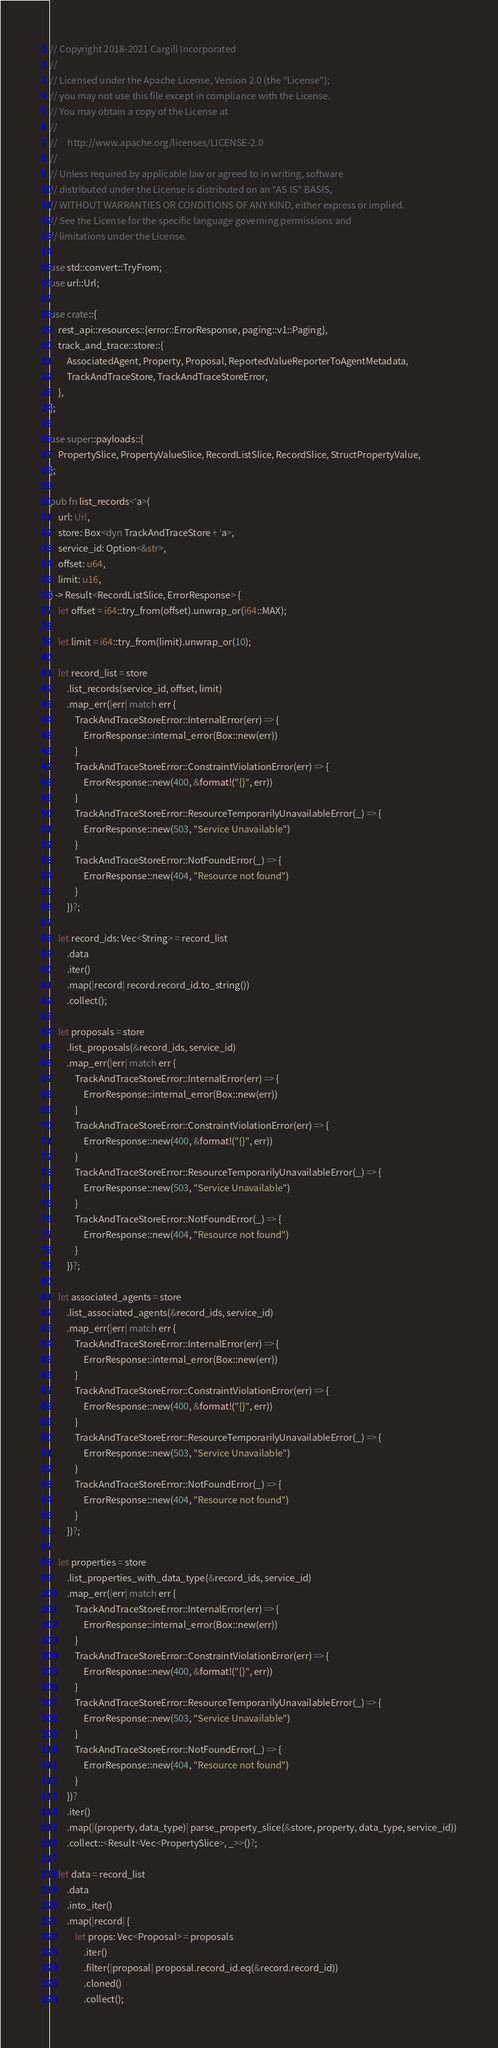<code> <loc_0><loc_0><loc_500><loc_500><_Rust_>// Copyright 2018-2021 Cargill Incorporated
//
// Licensed under the Apache License, Version 2.0 (the "License");
// you may not use this file except in compliance with the License.
// You may obtain a copy of the License at
//
//     http://www.apache.org/licenses/LICENSE-2.0
//
// Unless required by applicable law or agreed to in writing, software
// distributed under the License is distributed on an "AS IS" BASIS,
// WITHOUT WARRANTIES OR CONDITIONS OF ANY KIND, either express or implied.
// See the License for the specific language governing permissions and
// limitations under the License.

use std::convert::TryFrom;
use url::Url;

use crate::{
    rest_api::resources::{error::ErrorResponse, paging::v1::Paging},
    track_and_trace::store::{
        AssociatedAgent, Property, Proposal, ReportedValueReporterToAgentMetadata,
        TrackAndTraceStore, TrackAndTraceStoreError,
    },
};

use super::payloads::{
    PropertySlice, PropertyValueSlice, RecordListSlice, RecordSlice, StructPropertyValue,
};

pub fn list_records<'a>(
    url: Url,
    store: Box<dyn TrackAndTraceStore + 'a>,
    service_id: Option<&str>,
    offset: u64,
    limit: u16,
) -> Result<RecordListSlice, ErrorResponse> {
    let offset = i64::try_from(offset).unwrap_or(i64::MAX);

    let limit = i64::try_from(limit).unwrap_or(10);

    let record_list = store
        .list_records(service_id, offset, limit)
        .map_err(|err| match err {
            TrackAndTraceStoreError::InternalError(err) => {
                ErrorResponse::internal_error(Box::new(err))
            }
            TrackAndTraceStoreError::ConstraintViolationError(err) => {
                ErrorResponse::new(400, &format!("{}", err))
            }
            TrackAndTraceStoreError::ResourceTemporarilyUnavailableError(_) => {
                ErrorResponse::new(503, "Service Unavailable")
            }
            TrackAndTraceStoreError::NotFoundError(_) => {
                ErrorResponse::new(404, "Resource not found")
            }
        })?;

    let record_ids: Vec<String> = record_list
        .data
        .iter()
        .map(|record| record.record_id.to_string())
        .collect();

    let proposals = store
        .list_proposals(&record_ids, service_id)
        .map_err(|err| match err {
            TrackAndTraceStoreError::InternalError(err) => {
                ErrorResponse::internal_error(Box::new(err))
            }
            TrackAndTraceStoreError::ConstraintViolationError(err) => {
                ErrorResponse::new(400, &format!("{}", err))
            }
            TrackAndTraceStoreError::ResourceTemporarilyUnavailableError(_) => {
                ErrorResponse::new(503, "Service Unavailable")
            }
            TrackAndTraceStoreError::NotFoundError(_) => {
                ErrorResponse::new(404, "Resource not found")
            }
        })?;

    let associated_agents = store
        .list_associated_agents(&record_ids, service_id)
        .map_err(|err| match err {
            TrackAndTraceStoreError::InternalError(err) => {
                ErrorResponse::internal_error(Box::new(err))
            }
            TrackAndTraceStoreError::ConstraintViolationError(err) => {
                ErrorResponse::new(400, &format!("{}", err))
            }
            TrackAndTraceStoreError::ResourceTemporarilyUnavailableError(_) => {
                ErrorResponse::new(503, "Service Unavailable")
            }
            TrackAndTraceStoreError::NotFoundError(_) => {
                ErrorResponse::new(404, "Resource not found")
            }
        })?;

    let properties = store
        .list_properties_with_data_type(&record_ids, service_id)
        .map_err(|err| match err {
            TrackAndTraceStoreError::InternalError(err) => {
                ErrorResponse::internal_error(Box::new(err))
            }
            TrackAndTraceStoreError::ConstraintViolationError(err) => {
                ErrorResponse::new(400, &format!("{}", err))
            }
            TrackAndTraceStoreError::ResourceTemporarilyUnavailableError(_) => {
                ErrorResponse::new(503, "Service Unavailable")
            }
            TrackAndTraceStoreError::NotFoundError(_) => {
                ErrorResponse::new(404, "Resource not found")
            }
        })?
        .iter()
        .map(|(property, data_type)| parse_property_slice(&store, property, data_type, service_id))
        .collect::<Result<Vec<PropertySlice>, _>>()?;

    let data = record_list
        .data
        .into_iter()
        .map(|record| {
            let props: Vec<Proposal> = proposals
                .iter()
                .filter(|proposal| proposal.record_id.eq(&record.record_id))
                .cloned()
                .collect();</code> 